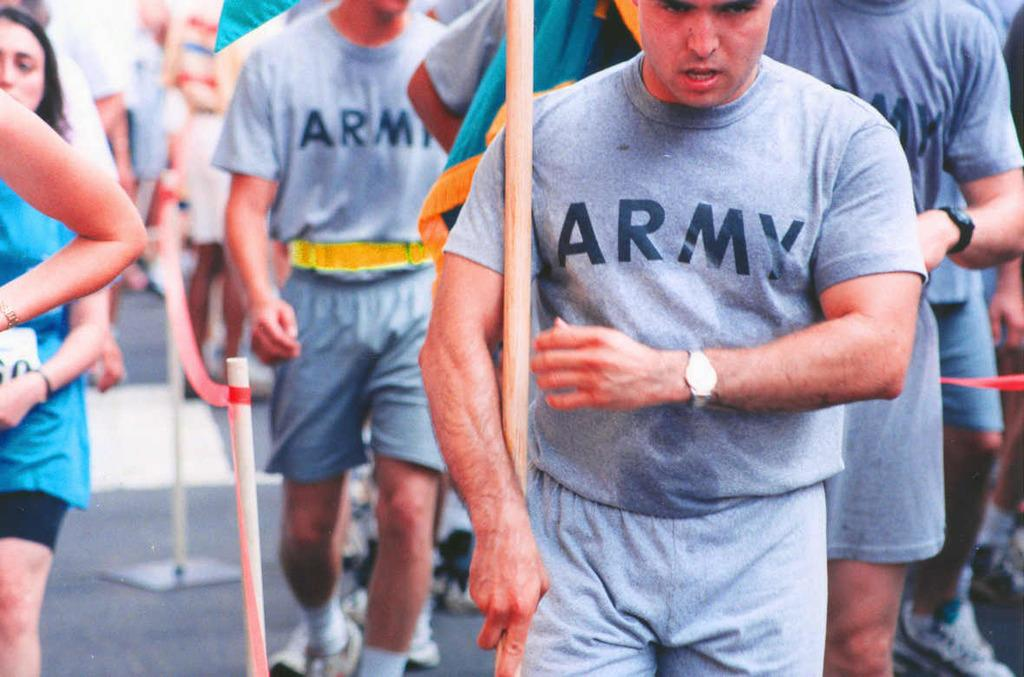<image>
Write a terse but informative summary of the picture. a man that is wearing an army shirt 